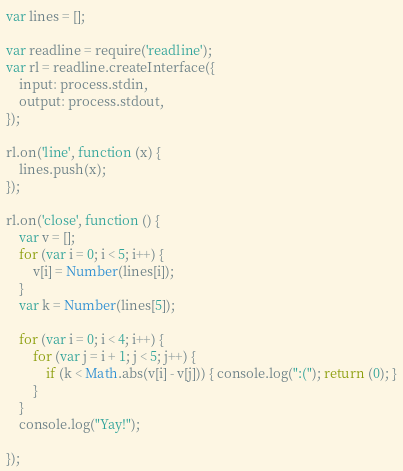<code> <loc_0><loc_0><loc_500><loc_500><_JavaScript_>var lines = [];

var readline = require('readline');
var rl = readline.createInterface({
    input: process.stdin,
    output: process.stdout,
});

rl.on('line', function (x) {
    lines.push(x);
});

rl.on('close', function () {
    var v = [];
    for (var i = 0; i < 5; i++) {
        v[i] = Number(lines[i]);
    }
    var k = Number(lines[5]);

    for (var i = 0; i < 4; i++) {
        for (var j = i + 1; j < 5; j++) {
            if (k < Math.abs(v[i] - v[j])) { console.log(":("); return (0); }
        }
    }
    console.log("Yay!");

});</code> 